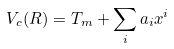<formula> <loc_0><loc_0><loc_500><loc_500>V _ { c } ( R ) = T _ { m } + \sum _ { i } a _ { i } x ^ { i }</formula> 